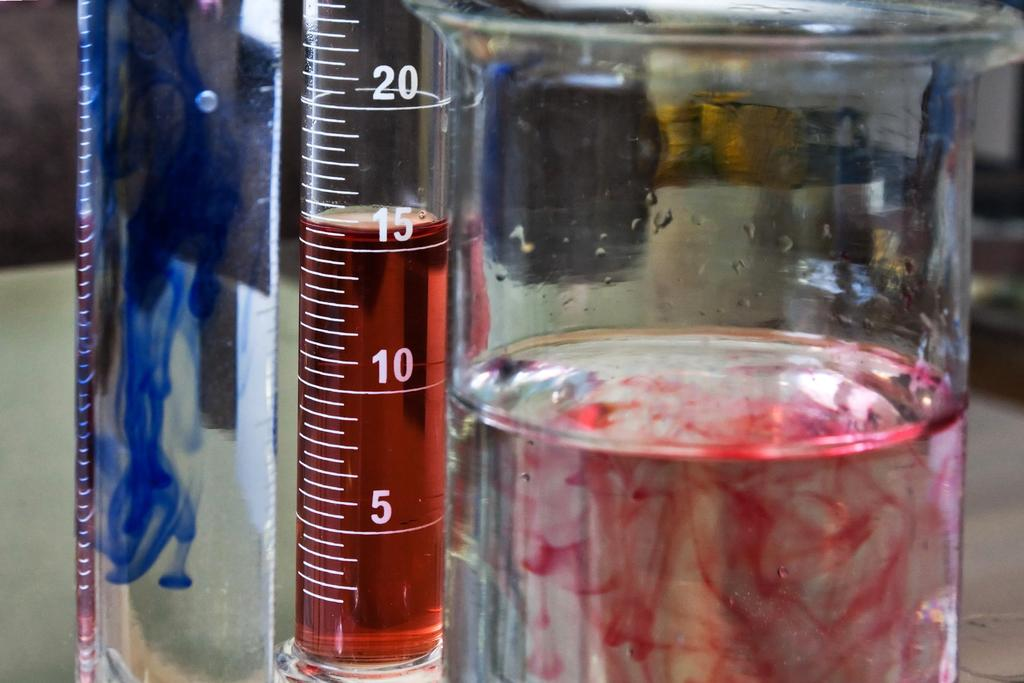<image>
Offer a succinct explanation of the picture presented. 3 glasses jar with liquid in them the red is at 15mm. 